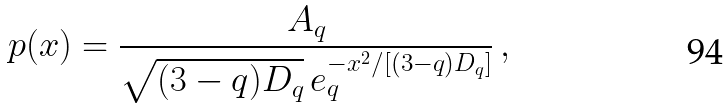Convert formula to latex. <formula><loc_0><loc_0><loc_500><loc_500>p ( x ) = \frac { A _ { q } } { \sqrt { ( 3 - q ) D _ { q } } \, e _ { q } ^ { - x ^ { 2 } / [ ( 3 - q ) D _ { q } ] } } \, ,</formula> 